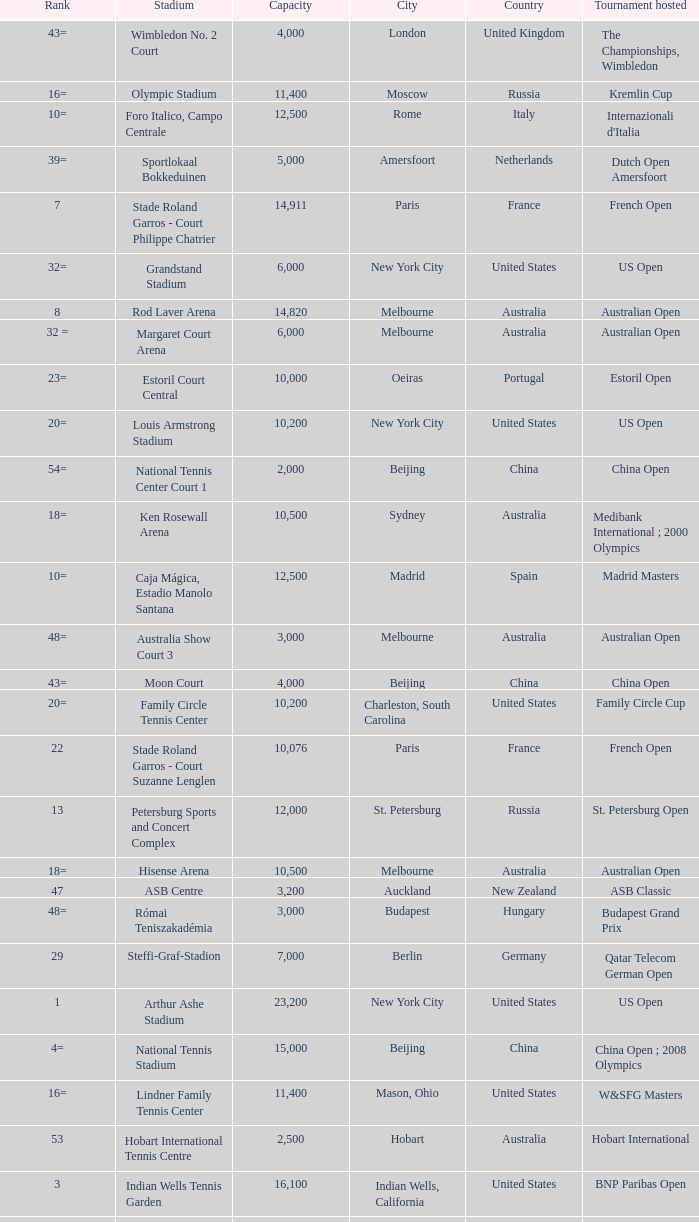What is the average capacity that has rod laver arena as the stadium? 14820.0. 